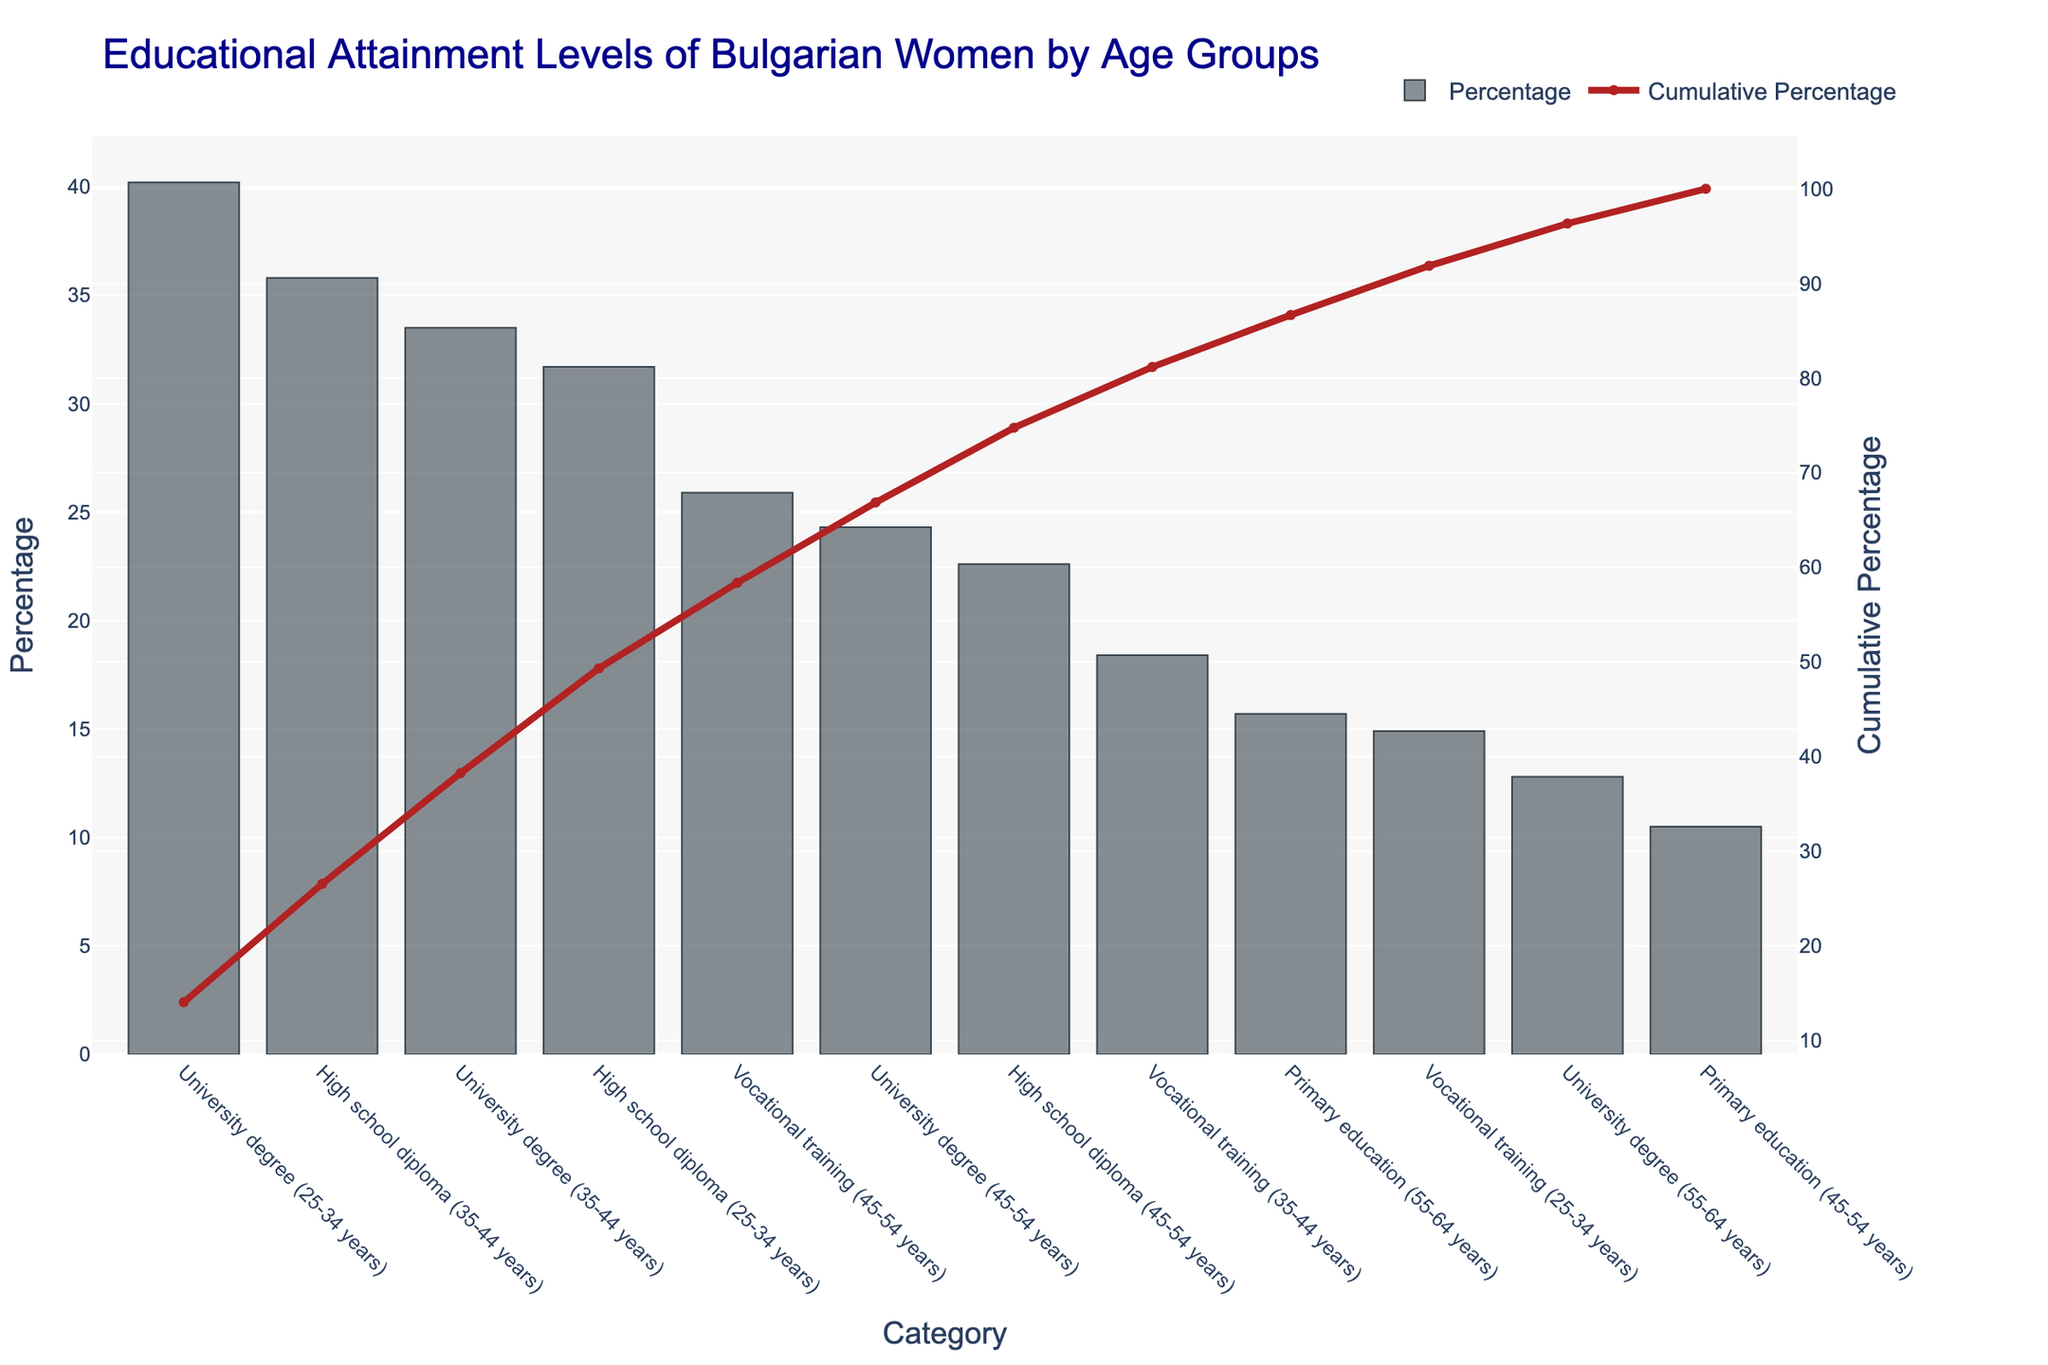What is the cumulative percentage for the category "University degree (25-34 years)"? Look at the "Cumulative Percentage" line on the y-axis for the data point "University degree (25-34 years)." The cumulative percentage is approximately 12%, corresponding to both axes.
Answer: 12 Which category has the highest percentage of educational attainment? Check the bar with the highest value on the vertical axis label "Percentage." "University degree (25-34 years)" has the highest percentage at 40.2%.
Answer: University degree (25-34 years) What is the total percentage of women with primary education in the age group 45-54 and 55-64? Add the percentages of the categories "Primary education (45-54 years)" and "Primary education (55-64 years)" from the chart: 10.5% + 15.7% = 26.2%.
Answer: 26.2% What is the percentage difference between "High school diploma (25-34 years)" and "University degree (55-64 years)"? Subtract the percentage of "University degree (55-64 years)" (12.8%) from "High school diploma (25-34 years)" (31.7%): 31.7% - 12.8% = 18.9%.
Answer: 18.9% What is the overall trend in university degree attainment across different age groups? From the chart, "University degree" percentages are highest on the left and decrease as you move to the right, showing a higher attainment in younger age groups (40.2% for 25-34 years, 33.5% for 35-44 years, and 24.3% for 45-54 years) and dropping to 12.8% in the 55-64 years group. This indicates a decreasing trend with older age groups.
Answer: Decreasing Which two age groups combined account for a cumulative percentage just over 50% for "High school diploma"? By referring to the cumulative percentage line in the chart, "High school diploma" categories are 35-44 years (35.8%) and 25-34 years (31.7%). The cumulative sum for these categories is 35.8% + 31.7% = 67.5%, which is over 50%.
Answer: 35-44 years, 25-34 years How does the percentage of "Vocational training" compare between the 25-34 years and 45-54 years age groups? Compare the bars representing "Vocational training (25-34 years)" and "Vocational training (45-54 years)." The 45-54 years group (25.9%) has a higher percentage than the 25-34 years group (14.9%).
Answer: Higher In which age group is "Primary education" the least common? Check the bar representing "Primary education" with the lowest value. The "Primary education (45-54 years)" has the lowest percentage at 10.5%.
Answer: 45-54 years What is the cumulative percentage after the category "High school diploma (35-44 years)"? Look at the cumulative percentage line at the category "High school diploma (35-44 years)." The value is just over 50%, around 60%.
Answer: About 60% Which category has the lowest percentage of educational attainment, and what is the percentage? Find the bar with the smallest height. The lowest educational attainment category is "Primary education (45-54 years)" with 10.5%.
Answer: Primary education (45-54 years), 10.5% 